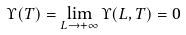Convert formula to latex. <formula><loc_0><loc_0><loc_500><loc_500>\Upsilon ( T ) = \lim _ { L \to + \infty } \Upsilon ( L , T ) = 0</formula> 